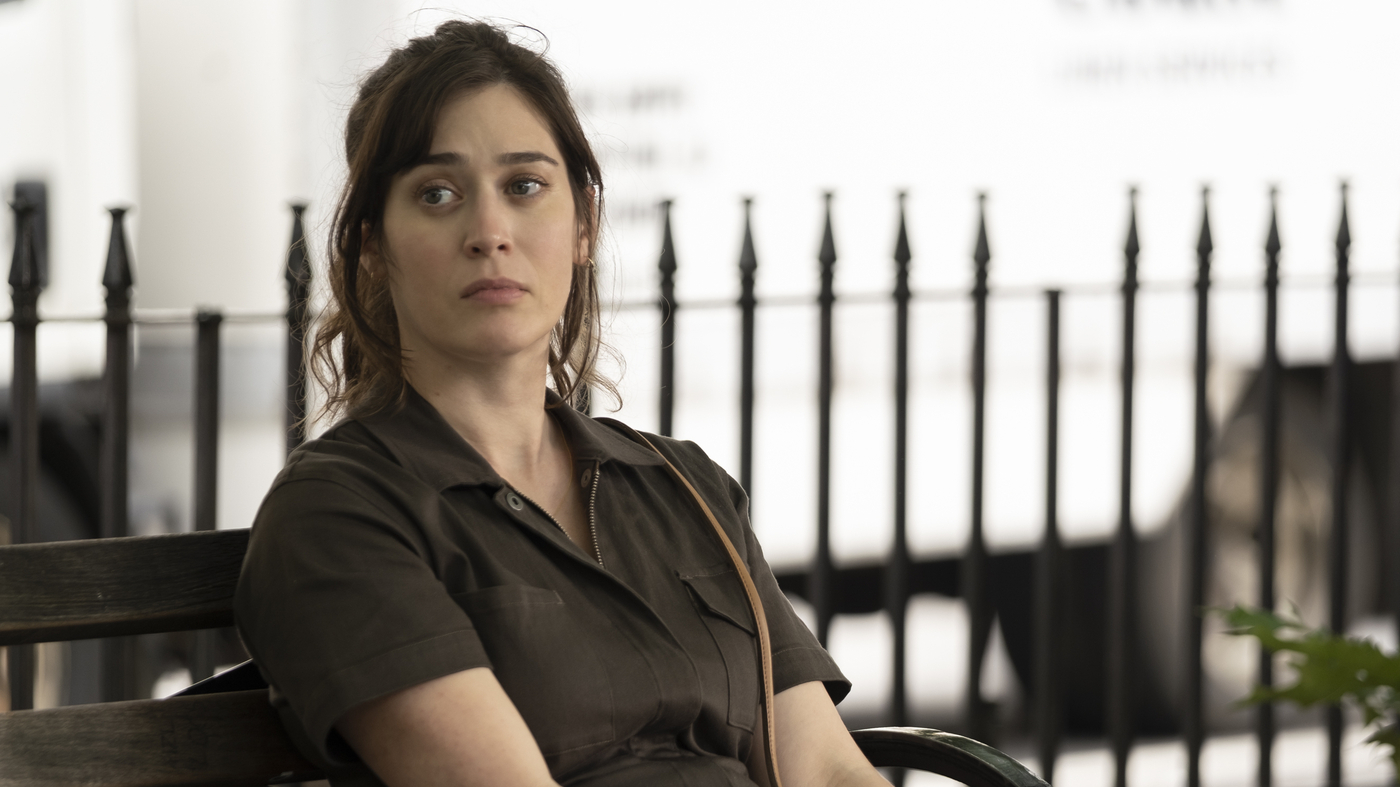What might the woman be thinking about? The woman's distant gaze and contemplative expression might suggest she is lost in thought, possibly reminiscing about a personal experience or pondering future decisions. The quiet setting further amplifies a serene moment of reflection. 